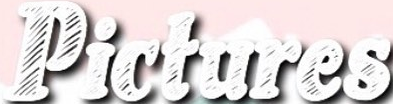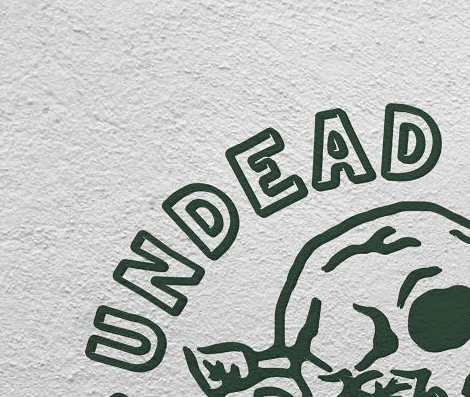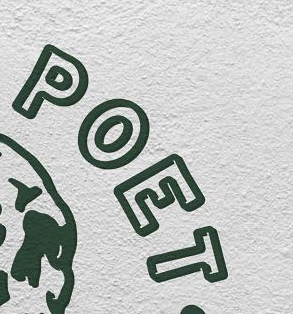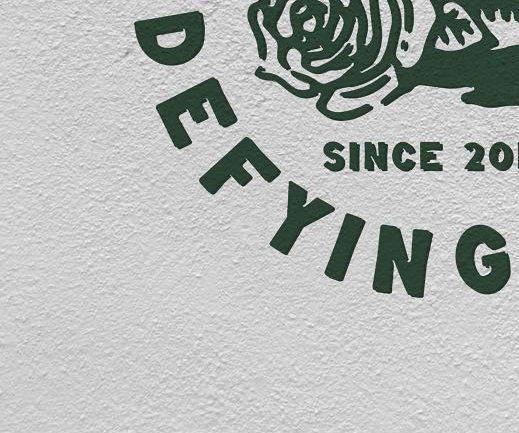Transcribe the words shown in these images in order, separated by a semicolon. Pictures; UNDEAD; POET; DEFYING 